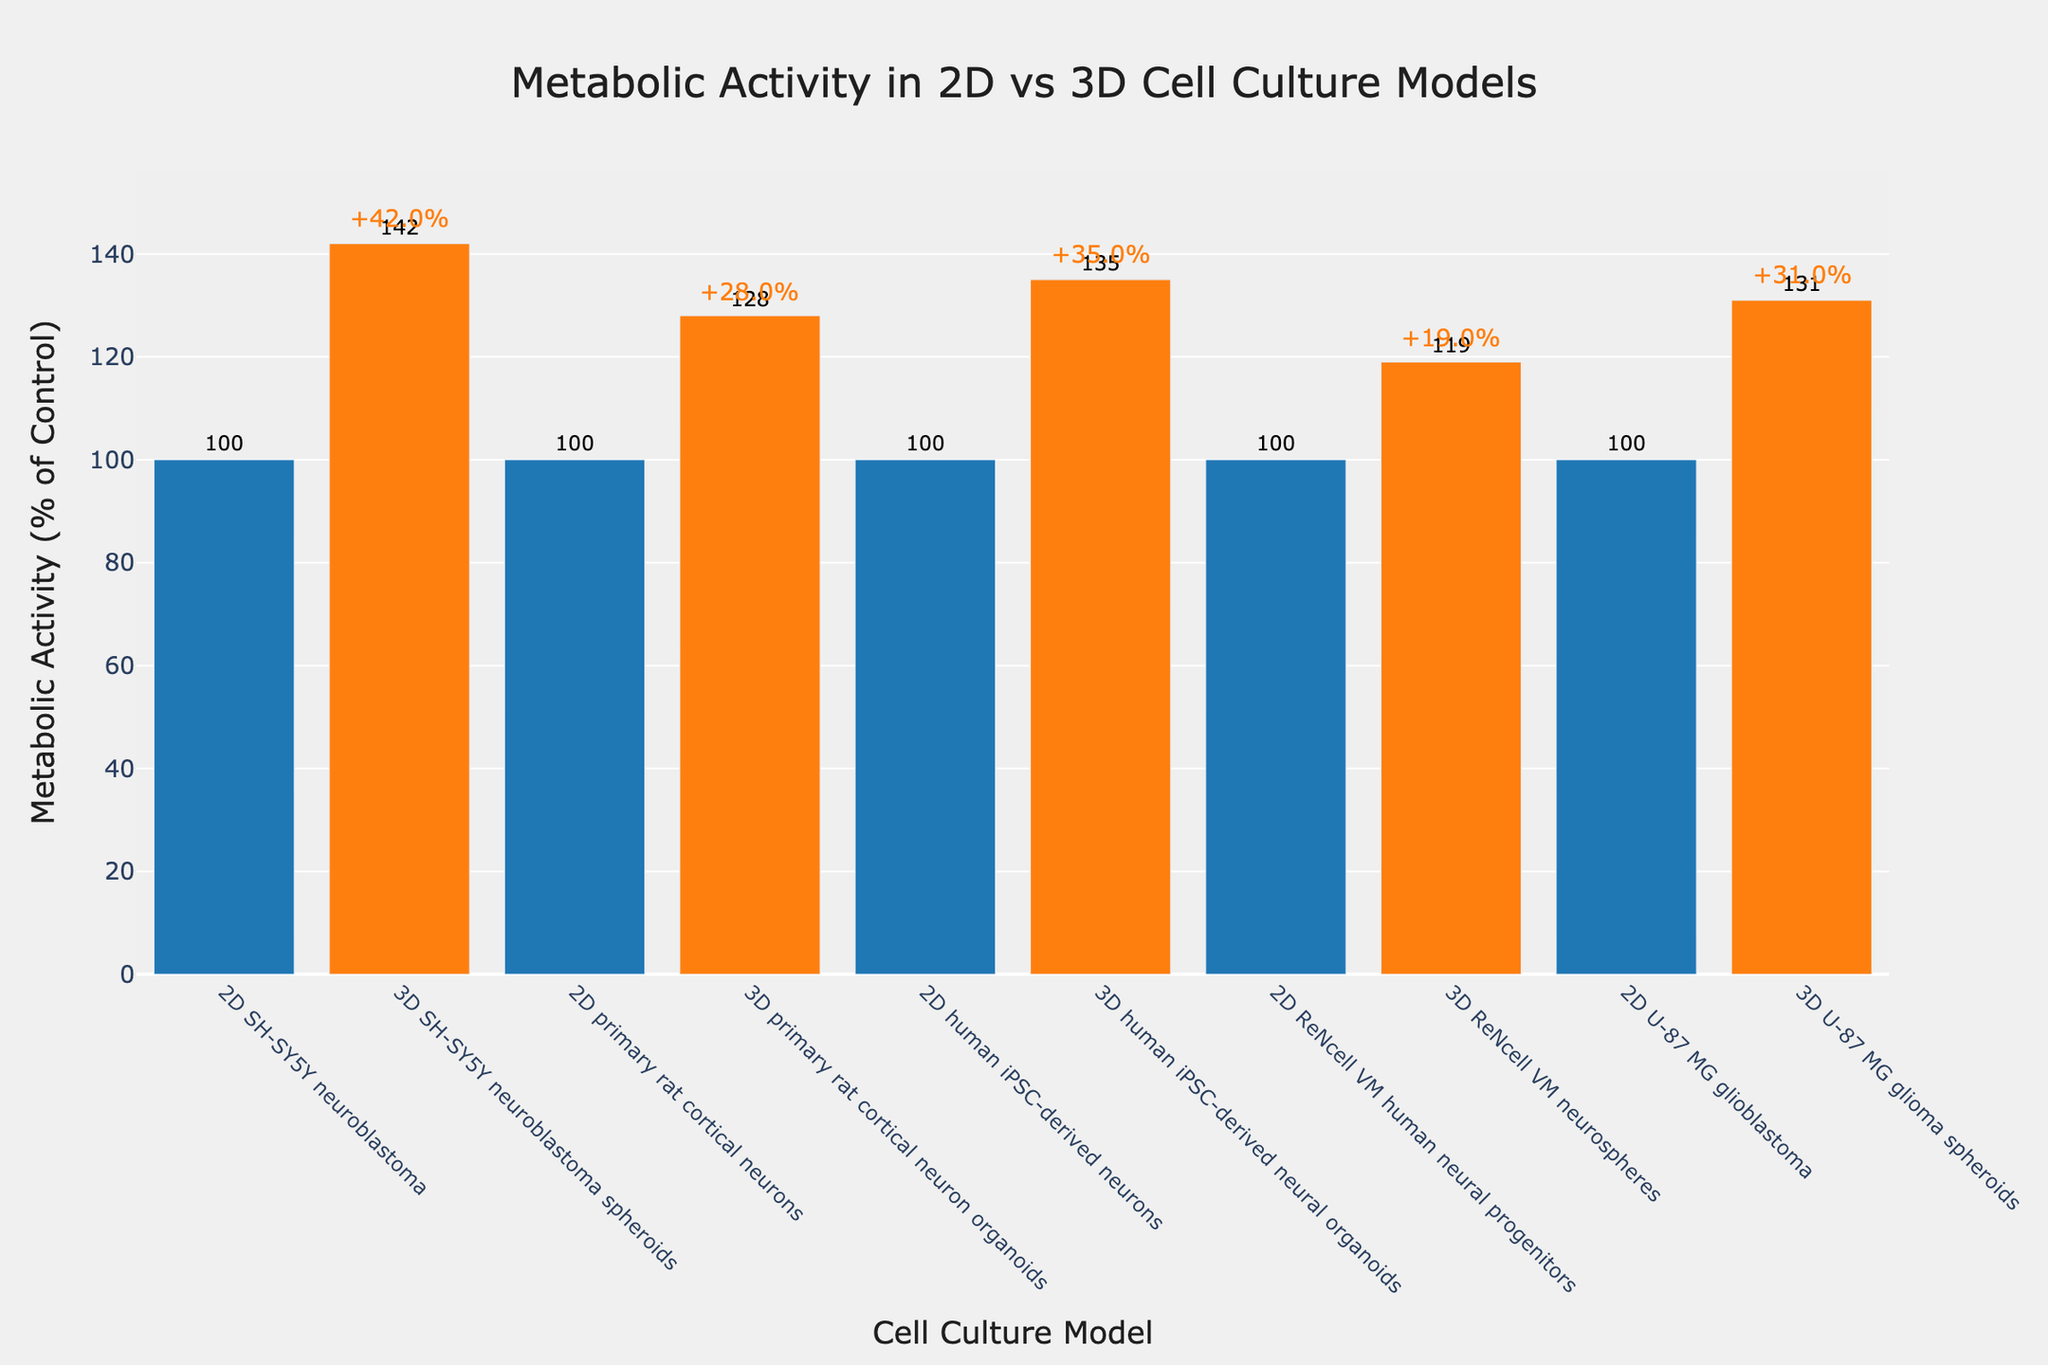what's the average metabolic activity across all 3D cell culture models? First, identify the metabolic activities of the 3D cell culture models: 142 (SH-SY5Y neuroblastoma spheroids), 128 (primary rat cortical neuron organoids), 135 (human iPSC-derived neural organoids), 119 (ReNcell VM neurospheres), and 131 (U-87 MG glioma spheroids). Sum these values: 142 + 128 + 135 + 119 + 131 = 655. Then, divide by the number of models (5): 655 / 5 = 131
Answer: 131 Which cell culture model has the highest metabolic activity? By examining the chart, locate the tallest bar, which represents the highest metabolic activity. The model corresponding to this bar is "3D SH-SY5Y neuroblastoma spheroids" with an activity of 142%.
Answer: 3D SH-SY5Y neuroblastoma spheroids What's the difference in metabolic activity between 3D SH-SY5Y neuroblastoma spheroids and 3D ReNcell VM neurospheres? Identify the metabolic activities of the two models from the figure: 142 (3D SH-SY5Y neuroblastoma spheroids) and 119 (3D ReNcell VM neurospheres). Subtract the latter from the former: 142 - 119 = 23.
Answer: 23 What is the relative increase in metabolic activity for 3D human iPSC-derived neural organoids compared to their 2D counterpart? The metabolic activity for 2D human iPSC-derived neurons is 100%, and for 3D human iPSC-derived neural organoids, it is 135%. The relative increase is calculated as: (135 - 100) / 100 * 100% = 35%.
Answer: 35% Which culture models exhibit metabolic activity greater than 130%? From the chart, identify the bars with activity greater than 130%. These are: 3D SH-SY5Y neuroblastoma spheroids (142%), 3D human iPSC-derived neural organoids (135%), and 3D U-87 MG glioma spheroids (131%).
Answer: 3D SH-SY5Y neuroblastoma spheroids, 3D human iPSC-derived neural organoids, 3D U-87 MG glioma spheroids Compare the average metabolic activity between all 2D and 3D models. Which has a higher average and by how much? Calculate the average for 2D models: (100 + 100 + 100 + 100 + 100) / 5 = 100%. Calculate the average for 3D models: (142 + 128 + 135 + 119 + 131) / 5 = 131%. The difference is: 131 - 100 = 31%.
Answer: 3D models have a higher average by 31% What is the color used to represent the 2D cell culture models? By visually inspecting the figure, the bars representing 2D cell culture models are colored blue.
Answer: blue How does the metabolic activity of 3D primary rat cortical neuron organoids compare to that of 2D ReNcell VM human neural progenitors? The metabolic activity of 3D primary rat cortical neuron organoids is 128%, while that of 2D ReNcell VM human neural progenitors is 100%. Thus, the 3D primary rat cortical neuron organoids have a higher metabolic activity.
Answer: 3D primary rat cortical neuron organoids have higher activity 